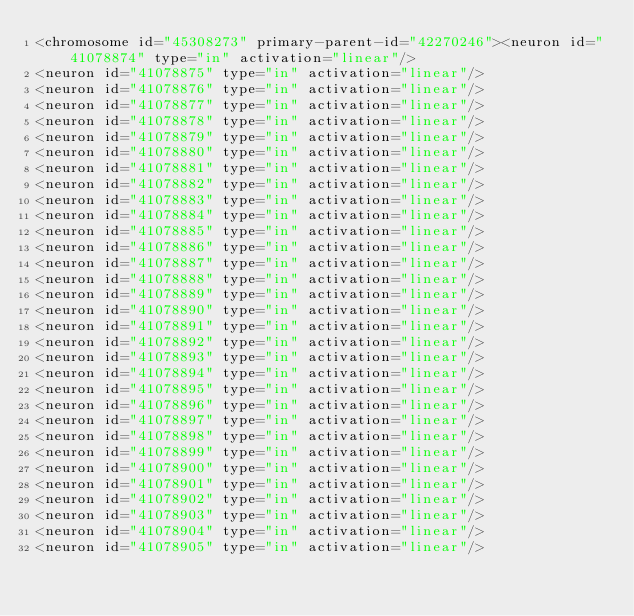<code> <loc_0><loc_0><loc_500><loc_500><_XML_><chromosome id="45308273" primary-parent-id="42270246"><neuron id="41078874" type="in" activation="linear"/>
<neuron id="41078875" type="in" activation="linear"/>
<neuron id="41078876" type="in" activation="linear"/>
<neuron id="41078877" type="in" activation="linear"/>
<neuron id="41078878" type="in" activation="linear"/>
<neuron id="41078879" type="in" activation="linear"/>
<neuron id="41078880" type="in" activation="linear"/>
<neuron id="41078881" type="in" activation="linear"/>
<neuron id="41078882" type="in" activation="linear"/>
<neuron id="41078883" type="in" activation="linear"/>
<neuron id="41078884" type="in" activation="linear"/>
<neuron id="41078885" type="in" activation="linear"/>
<neuron id="41078886" type="in" activation="linear"/>
<neuron id="41078887" type="in" activation="linear"/>
<neuron id="41078888" type="in" activation="linear"/>
<neuron id="41078889" type="in" activation="linear"/>
<neuron id="41078890" type="in" activation="linear"/>
<neuron id="41078891" type="in" activation="linear"/>
<neuron id="41078892" type="in" activation="linear"/>
<neuron id="41078893" type="in" activation="linear"/>
<neuron id="41078894" type="in" activation="linear"/>
<neuron id="41078895" type="in" activation="linear"/>
<neuron id="41078896" type="in" activation="linear"/>
<neuron id="41078897" type="in" activation="linear"/>
<neuron id="41078898" type="in" activation="linear"/>
<neuron id="41078899" type="in" activation="linear"/>
<neuron id="41078900" type="in" activation="linear"/>
<neuron id="41078901" type="in" activation="linear"/>
<neuron id="41078902" type="in" activation="linear"/>
<neuron id="41078903" type="in" activation="linear"/>
<neuron id="41078904" type="in" activation="linear"/>
<neuron id="41078905" type="in" activation="linear"/></code> 